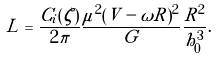Convert formula to latex. <formula><loc_0><loc_0><loc_500><loc_500>L = \frac { C _ { i } ( \zeta ) } { 2 \pi } \frac { \mu ^ { 2 } ( V - \omega R ) ^ { 2 } } { G } \frac { R ^ { 2 } } { h _ { 0 } ^ { 3 } } .</formula> 